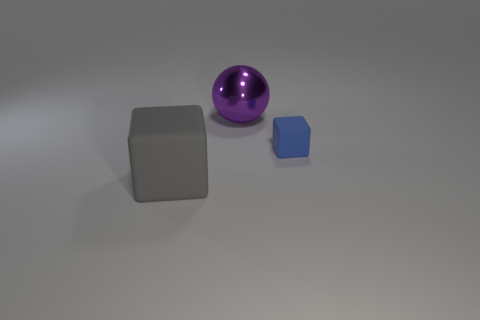The block that is made of the same material as the small object is what color?
Your response must be concise. Gray. There is a large matte object; does it have the same shape as the big object that is behind the blue object?
Keep it short and to the point. No. There is a cube that is the same size as the shiny ball; what material is it?
Your response must be concise. Rubber. Are there any large metallic things of the same color as the small matte block?
Provide a short and direct response. No. What shape is the thing that is both right of the gray matte cube and in front of the purple thing?
Your answer should be compact. Cube. What number of other things are made of the same material as the gray thing?
Your answer should be very brief. 1. Are there fewer gray rubber things that are behind the gray rubber object than metallic things that are behind the purple ball?
Make the answer very short. No. There is a object that is behind the cube that is behind the cube that is to the left of the tiny cube; what is it made of?
Your answer should be compact. Metal. There is a thing that is both to the left of the blue matte thing and in front of the big purple metallic ball; how big is it?
Your response must be concise. Large. How many spheres are either large yellow shiny objects or big purple things?
Keep it short and to the point. 1. 